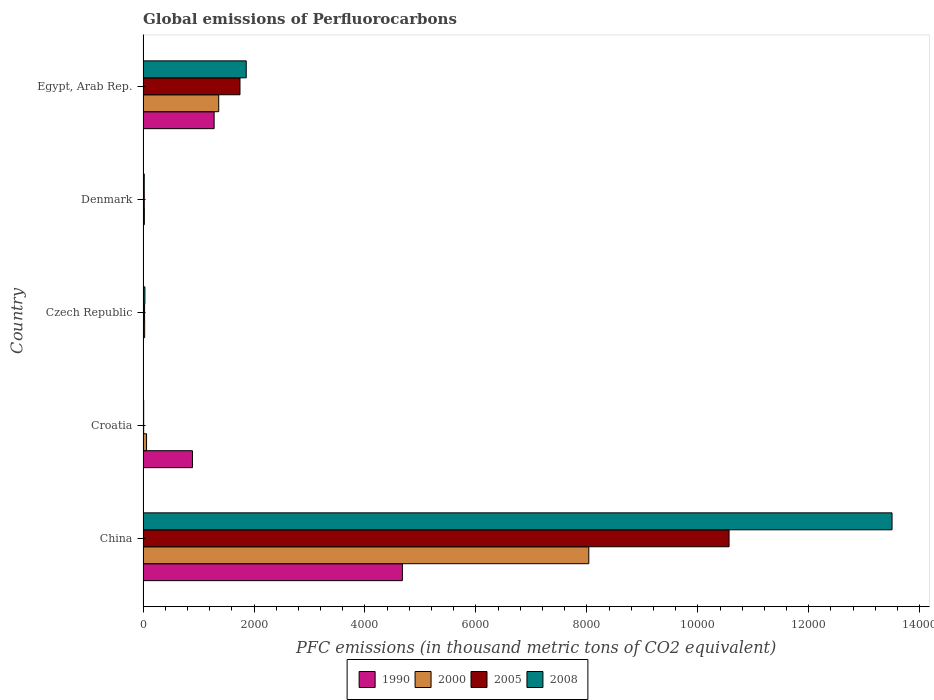How many different coloured bars are there?
Your response must be concise. 4. Are the number of bars per tick equal to the number of legend labels?
Keep it short and to the point. Yes. How many bars are there on the 5th tick from the top?
Make the answer very short. 4. How many bars are there on the 2nd tick from the bottom?
Make the answer very short. 4. What is the label of the 2nd group of bars from the top?
Your answer should be compact. Denmark. In how many cases, is the number of bars for a given country not equal to the number of legend labels?
Your response must be concise. 0. Across all countries, what is the maximum global emissions of Perfluorocarbons in 2000?
Provide a short and direct response. 8034.4. Across all countries, what is the minimum global emissions of Perfluorocarbons in 2008?
Provide a succinct answer. 11. In which country was the global emissions of Perfluorocarbons in 2008 maximum?
Ensure brevity in your answer.  China. In which country was the global emissions of Perfluorocarbons in 2005 minimum?
Your answer should be compact. Croatia. What is the total global emissions of Perfluorocarbons in 2005 in the graph?
Your answer should be compact. 1.24e+04. What is the difference between the global emissions of Perfluorocarbons in 1990 in China and that in Czech Republic?
Your answer should be compact. 4671.7. What is the difference between the global emissions of Perfluorocarbons in 1990 in Egypt, Arab Rep. and the global emissions of Perfluorocarbons in 2008 in Denmark?
Ensure brevity in your answer.  1259.4. What is the average global emissions of Perfluorocarbons in 1990 per country?
Provide a short and direct response. 1369.98. What is the difference between the global emissions of Perfluorocarbons in 2000 and global emissions of Perfluorocarbons in 2005 in China?
Your answer should be compact. -2528.4. In how many countries, is the global emissions of Perfluorocarbons in 2000 greater than 10800 thousand metric tons?
Give a very brief answer. 0. What is the ratio of the global emissions of Perfluorocarbons in 2008 in Croatia to that in Egypt, Arab Rep.?
Make the answer very short. 0.01. Is the global emissions of Perfluorocarbons in 1990 in China less than that in Croatia?
Offer a terse response. No. Is the difference between the global emissions of Perfluorocarbons in 2000 in Denmark and Egypt, Arab Rep. greater than the difference between the global emissions of Perfluorocarbons in 2005 in Denmark and Egypt, Arab Rep.?
Offer a terse response. Yes. What is the difference between the highest and the second highest global emissions of Perfluorocarbons in 2008?
Your answer should be compact. 1.16e+04. What is the difference between the highest and the lowest global emissions of Perfluorocarbons in 1990?
Give a very brief answer. 4673.1. In how many countries, is the global emissions of Perfluorocarbons in 2000 greater than the average global emissions of Perfluorocarbons in 2000 taken over all countries?
Provide a short and direct response. 1. Is the sum of the global emissions of Perfluorocarbons in 1990 in Croatia and Denmark greater than the maximum global emissions of Perfluorocarbons in 2000 across all countries?
Offer a very short reply. No. Is it the case that in every country, the sum of the global emissions of Perfluorocarbons in 2008 and global emissions of Perfluorocarbons in 1990 is greater than the sum of global emissions of Perfluorocarbons in 2005 and global emissions of Perfluorocarbons in 2000?
Give a very brief answer. No. How many bars are there?
Provide a short and direct response. 20. Are all the bars in the graph horizontal?
Your answer should be very brief. Yes. Does the graph contain any zero values?
Your answer should be very brief. No. Where does the legend appear in the graph?
Ensure brevity in your answer.  Bottom center. How many legend labels are there?
Offer a terse response. 4. What is the title of the graph?
Ensure brevity in your answer.  Global emissions of Perfluorocarbons. Does "2015" appear as one of the legend labels in the graph?
Provide a succinct answer. No. What is the label or title of the X-axis?
Give a very brief answer. PFC emissions (in thousand metric tons of CO2 equivalent). What is the PFC emissions (in thousand metric tons of CO2 equivalent) in 1990 in China?
Give a very brief answer. 4674.5. What is the PFC emissions (in thousand metric tons of CO2 equivalent) in 2000 in China?
Your response must be concise. 8034.4. What is the PFC emissions (in thousand metric tons of CO2 equivalent) in 2005 in China?
Make the answer very short. 1.06e+04. What is the PFC emissions (in thousand metric tons of CO2 equivalent) in 2008 in China?
Make the answer very short. 1.35e+04. What is the PFC emissions (in thousand metric tons of CO2 equivalent) of 1990 in Croatia?
Ensure brevity in your answer.  890.4. What is the PFC emissions (in thousand metric tons of CO2 equivalent) of 2000 in Croatia?
Your answer should be compact. 63. What is the PFC emissions (in thousand metric tons of CO2 equivalent) in 2000 in Czech Republic?
Offer a terse response. 28.8. What is the PFC emissions (in thousand metric tons of CO2 equivalent) in 2005 in Czech Republic?
Your answer should be compact. 27.5. What is the PFC emissions (in thousand metric tons of CO2 equivalent) in 2008 in Czech Republic?
Give a very brief answer. 33.3. What is the PFC emissions (in thousand metric tons of CO2 equivalent) in 1990 in Denmark?
Keep it short and to the point. 1.4. What is the PFC emissions (in thousand metric tons of CO2 equivalent) in 2000 in Denmark?
Your answer should be compact. 23.4. What is the PFC emissions (in thousand metric tons of CO2 equivalent) in 2008 in Denmark?
Give a very brief answer. 21.4. What is the PFC emissions (in thousand metric tons of CO2 equivalent) in 1990 in Egypt, Arab Rep.?
Your answer should be very brief. 1280.8. What is the PFC emissions (in thousand metric tons of CO2 equivalent) in 2000 in Egypt, Arab Rep.?
Provide a succinct answer. 1363.8. What is the PFC emissions (in thousand metric tons of CO2 equivalent) in 2005 in Egypt, Arab Rep.?
Provide a short and direct response. 1747.1. What is the PFC emissions (in thousand metric tons of CO2 equivalent) in 2008 in Egypt, Arab Rep.?
Your answer should be very brief. 1859.8. Across all countries, what is the maximum PFC emissions (in thousand metric tons of CO2 equivalent) in 1990?
Ensure brevity in your answer.  4674.5. Across all countries, what is the maximum PFC emissions (in thousand metric tons of CO2 equivalent) in 2000?
Offer a terse response. 8034.4. Across all countries, what is the maximum PFC emissions (in thousand metric tons of CO2 equivalent) of 2005?
Provide a short and direct response. 1.06e+04. Across all countries, what is the maximum PFC emissions (in thousand metric tons of CO2 equivalent) in 2008?
Ensure brevity in your answer.  1.35e+04. Across all countries, what is the minimum PFC emissions (in thousand metric tons of CO2 equivalent) in 1990?
Keep it short and to the point. 1.4. Across all countries, what is the minimum PFC emissions (in thousand metric tons of CO2 equivalent) of 2000?
Offer a terse response. 23.4. Across all countries, what is the minimum PFC emissions (in thousand metric tons of CO2 equivalent) of 2005?
Ensure brevity in your answer.  10.9. What is the total PFC emissions (in thousand metric tons of CO2 equivalent) in 1990 in the graph?
Make the answer very short. 6849.9. What is the total PFC emissions (in thousand metric tons of CO2 equivalent) in 2000 in the graph?
Your answer should be compact. 9513.4. What is the total PFC emissions (in thousand metric tons of CO2 equivalent) of 2005 in the graph?
Ensure brevity in your answer.  1.24e+04. What is the total PFC emissions (in thousand metric tons of CO2 equivalent) of 2008 in the graph?
Ensure brevity in your answer.  1.54e+04. What is the difference between the PFC emissions (in thousand metric tons of CO2 equivalent) of 1990 in China and that in Croatia?
Ensure brevity in your answer.  3784.1. What is the difference between the PFC emissions (in thousand metric tons of CO2 equivalent) in 2000 in China and that in Croatia?
Make the answer very short. 7971.4. What is the difference between the PFC emissions (in thousand metric tons of CO2 equivalent) in 2005 in China and that in Croatia?
Ensure brevity in your answer.  1.06e+04. What is the difference between the PFC emissions (in thousand metric tons of CO2 equivalent) in 2008 in China and that in Croatia?
Provide a succinct answer. 1.35e+04. What is the difference between the PFC emissions (in thousand metric tons of CO2 equivalent) of 1990 in China and that in Czech Republic?
Your answer should be compact. 4671.7. What is the difference between the PFC emissions (in thousand metric tons of CO2 equivalent) in 2000 in China and that in Czech Republic?
Your response must be concise. 8005.6. What is the difference between the PFC emissions (in thousand metric tons of CO2 equivalent) in 2005 in China and that in Czech Republic?
Your answer should be compact. 1.05e+04. What is the difference between the PFC emissions (in thousand metric tons of CO2 equivalent) in 2008 in China and that in Czech Republic?
Provide a short and direct response. 1.35e+04. What is the difference between the PFC emissions (in thousand metric tons of CO2 equivalent) of 1990 in China and that in Denmark?
Keep it short and to the point. 4673.1. What is the difference between the PFC emissions (in thousand metric tons of CO2 equivalent) in 2000 in China and that in Denmark?
Offer a terse response. 8011. What is the difference between the PFC emissions (in thousand metric tons of CO2 equivalent) of 2005 in China and that in Denmark?
Offer a terse response. 1.05e+04. What is the difference between the PFC emissions (in thousand metric tons of CO2 equivalent) of 2008 in China and that in Denmark?
Your answer should be compact. 1.35e+04. What is the difference between the PFC emissions (in thousand metric tons of CO2 equivalent) of 1990 in China and that in Egypt, Arab Rep.?
Keep it short and to the point. 3393.7. What is the difference between the PFC emissions (in thousand metric tons of CO2 equivalent) in 2000 in China and that in Egypt, Arab Rep.?
Give a very brief answer. 6670.6. What is the difference between the PFC emissions (in thousand metric tons of CO2 equivalent) in 2005 in China and that in Egypt, Arab Rep.?
Provide a succinct answer. 8815.7. What is the difference between the PFC emissions (in thousand metric tons of CO2 equivalent) in 2008 in China and that in Egypt, Arab Rep.?
Keep it short and to the point. 1.16e+04. What is the difference between the PFC emissions (in thousand metric tons of CO2 equivalent) in 1990 in Croatia and that in Czech Republic?
Provide a short and direct response. 887.6. What is the difference between the PFC emissions (in thousand metric tons of CO2 equivalent) of 2000 in Croatia and that in Czech Republic?
Provide a short and direct response. 34.2. What is the difference between the PFC emissions (in thousand metric tons of CO2 equivalent) in 2005 in Croatia and that in Czech Republic?
Ensure brevity in your answer.  -16.6. What is the difference between the PFC emissions (in thousand metric tons of CO2 equivalent) in 2008 in Croatia and that in Czech Republic?
Your response must be concise. -22.3. What is the difference between the PFC emissions (in thousand metric tons of CO2 equivalent) of 1990 in Croatia and that in Denmark?
Your response must be concise. 889. What is the difference between the PFC emissions (in thousand metric tons of CO2 equivalent) in 2000 in Croatia and that in Denmark?
Provide a short and direct response. 39.6. What is the difference between the PFC emissions (in thousand metric tons of CO2 equivalent) of 1990 in Croatia and that in Egypt, Arab Rep.?
Provide a succinct answer. -390.4. What is the difference between the PFC emissions (in thousand metric tons of CO2 equivalent) in 2000 in Croatia and that in Egypt, Arab Rep.?
Your response must be concise. -1300.8. What is the difference between the PFC emissions (in thousand metric tons of CO2 equivalent) of 2005 in Croatia and that in Egypt, Arab Rep.?
Offer a very short reply. -1736.2. What is the difference between the PFC emissions (in thousand metric tons of CO2 equivalent) of 2008 in Croatia and that in Egypt, Arab Rep.?
Offer a terse response. -1848.8. What is the difference between the PFC emissions (in thousand metric tons of CO2 equivalent) of 1990 in Czech Republic and that in Denmark?
Make the answer very short. 1.4. What is the difference between the PFC emissions (in thousand metric tons of CO2 equivalent) in 2000 in Czech Republic and that in Denmark?
Provide a succinct answer. 5.4. What is the difference between the PFC emissions (in thousand metric tons of CO2 equivalent) in 1990 in Czech Republic and that in Egypt, Arab Rep.?
Give a very brief answer. -1278. What is the difference between the PFC emissions (in thousand metric tons of CO2 equivalent) of 2000 in Czech Republic and that in Egypt, Arab Rep.?
Keep it short and to the point. -1335. What is the difference between the PFC emissions (in thousand metric tons of CO2 equivalent) in 2005 in Czech Republic and that in Egypt, Arab Rep.?
Keep it short and to the point. -1719.6. What is the difference between the PFC emissions (in thousand metric tons of CO2 equivalent) of 2008 in Czech Republic and that in Egypt, Arab Rep.?
Ensure brevity in your answer.  -1826.5. What is the difference between the PFC emissions (in thousand metric tons of CO2 equivalent) in 1990 in Denmark and that in Egypt, Arab Rep.?
Make the answer very short. -1279.4. What is the difference between the PFC emissions (in thousand metric tons of CO2 equivalent) in 2000 in Denmark and that in Egypt, Arab Rep.?
Offer a very short reply. -1340.4. What is the difference between the PFC emissions (in thousand metric tons of CO2 equivalent) of 2005 in Denmark and that in Egypt, Arab Rep.?
Keep it short and to the point. -1725.6. What is the difference between the PFC emissions (in thousand metric tons of CO2 equivalent) in 2008 in Denmark and that in Egypt, Arab Rep.?
Your answer should be very brief. -1838.4. What is the difference between the PFC emissions (in thousand metric tons of CO2 equivalent) of 1990 in China and the PFC emissions (in thousand metric tons of CO2 equivalent) of 2000 in Croatia?
Your answer should be compact. 4611.5. What is the difference between the PFC emissions (in thousand metric tons of CO2 equivalent) in 1990 in China and the PFC emissions (in thousand metric tons of CO2 equivalent) in 2005 in Croatia?
Your response must be concise. 4663.6. What is the difference between the PFC emissions (in thousand metric tons of CO2 equivalent) in 1990 in China and the PFC emissions (in thousand metric tons of CO2 equivalent) in 2008 in Croatia?
Make the answer very short. 4663.5. What is the difference between the PFC emissions (in thousand metric tons of CO2 equivalent) of 2000 in China and the PFC emissions (in thousand metric tons of CO2 equivalent) of 2005 in Croatia?
Your answer should be very brief. 8023.5. What is the difference between the PFC emissions (in thousand metric tons of CO2 equivalent) in 2000 in China and the PFC emissions (in thousand metric tons of CO2 equivalent) in 2008 in Croatia?
Ensure brevity in your answer.  8023.4. What is the difference between the PFC emissions (in thousand metric tons of CO2 equivalent) in 2005 in China and the PFC emissions (in thousand metric tons of CO2 equivalent) in 2008 in Croatia?
Make the answer very short. 1.06e+04. What is the difference between the PFC emissions (in thousand metric tons of CO2 equivalent) of 1990 in China and the PFC emissions (in thousand metric tons of CO2 equivalent) of 2000 in Czech Republic?
Provide a succinct answer. 4645.7. What is the difference between the PFC emissions (in thousand metric tons of CO2 equivalent) in 1990 in China and the PFC emissions (in thousand metric tons of CO2 equivalent) in 2005 in Czech Republic?
Make the answer very short. 4647. What is the difference between the PFC emissions (in thousand metric tons of CO2 equivalent) in 1990 in China and the PFC emissions (in thousand metric tons of CO2 equivalent) in 2008 in Czech Republic?
Give a very brief answer. 4641.2. What is the difference between the PFC emissions (in thousand metric tons of CO2 equivalent) of 2000 in China and the PFC emissions (in thousand metric tons of CO2 equivalent) of 2005 in Czech Republic?
Provide a short and direct response. 8006.9. What is the difference between the PFC emissions (in thousand metric tons of CO2 equivalent) in 2000 in China and the PFC emissions (in thousand metric tons of CO2 equivalent) in 2008 in Czech Republic?
Your response must be concise. 8001.1. What is the difference between the PFC emissions (in thousand metric tons of CO2 equivalent) of 2005 in China and the PFC emissions (in thousand metric tons of CO2 equivalent) of 2008 in Czech Republic?
Your answer should be compact. 1.05e+04. What is the difference between the PFC emissions (in thousand metric tons of CO2 equivalent) in 1990 in China and the PFC emissions (in thousand metric tons of CO2 equivalent) in 2000 in Denmark?
Your answer should be very brief. 4651.1. What is the difference between the PFC emissions (in thousand metric tons of CO2 equivalent) of 1990 in China and the PFC emissions (in thousand metric tons of CO2 equivalent) of 2005 in Denmark?
Provide a short and direct response. 4653. What is the difference between the PFC emissions (in thousand metric tons of CO2 equivalent) of 1990 in China and the PFC emissions (in thousand metric tons of CO2 equivalent) of 2008 in Denmark?
Keep it short and to the point. 4653.1. What is the difference between the PFC emissions (in thousand metric tons of CO2 equivalent) of 2000 in China and the PFC emissions (in thousand metric tons of CO2 equivalent) of 2005 in Denmark?
Provide a succinct answer. 8012.9. What is the difference between the PFC emissions (in thousand metric tons of CO2 equivalent) of 2000 in China and the PFC emissions (in thousand metric tons of CO2 equivalent) of 2008 in Denmark?
Ensure brevity in your answer.  8013. What is the difference between the PFC emissions (in thousand metric tons of CO2 equivalent) in 2005 in China and the PFC emissions (in thousand metric tons of CO2 equivalent) in 2008 in Denmark?
Keep it short and to the point. 1.05e+04. What is the difference between the PFC emissions (in thousand metric tons of CO2 equivalent) of 1990 in China and the PFC emissions (in thousand metric tons of CO2 equivalent) of 2000 in Egypt, Arab Rep.?
Give a very brief answer. 3310.7. What is the difference between the PFC emissions (in thousand metric tons of CO2 equivalent) of 1990 in China and the PFC emissions (in thousand metric tons of CO2 equivalent) of 2005 in Egypt, Arab Rep.?
Make the answer very short. 2927.4. What is the difference between the PFC emissions (in thousand metric tons of CO2 equivalent) of 1990 in China and the PFC emissions (in thousand metric tons of CO2 equivalent) of 2008 in Egypt, Arab Rep.?
Provide a succinct answer. 2814.7. What is the difference between the PFC emissions (in thousand metric tons of CO2 equivalent) of 2000 in China and the PFC emissions (in thousand metric tons of CO2 equivalent) of 2005 in Egypt, Arab Rep.?
Offer a terse response. 6287.3. What is the difference between the PFC emissions (in thousand metric tons of CO2 equivalent) of 2000 in China and the PFC emissions (in thousand metric tons of CO2 equivalent) of 2008 in Egypt, Arab Rep.?
Ensure brevity in your answer.  6174.6. What is the difference between the PFC emissions (in thousand metric tons of CO2 equivalent) in 2005 in China and the PFC emissions (in thousand metric tons of CO2 equivalent) in 2008 in Egypt, Arab Rep.?
Ensure brevity in your answer.  8703. What is the difference between the PFC emissions (in thousand metric tons of CO2 equivalent) in 1990 in Croatia and the PFC emissions (in thousand metric tons of CO2 equivalent) in 2000 in Czech Republic?
Make the answer very short. 861.6. What is the difference between the PFC emissions (in thousand metric tons of CO2 equivalent) of 1990 in Croatia and the PFC emissions (in thousand metric tons of CO2 equivalent) of 2005 in Czech Republic?
Your answer should be very brief. 862.9. What is the difference between the PFC emissions (in thousand metric tons of CO2 equivalent) in 1990 in Croatia and the PFC emissions (in thousand metric tons of CO2 equivalent) in 2008 in Czech Republic?
Keep it short and to the point. 857.1. What is the difference between the PFC emissions (in thousand metric tons of CO2 equivalent) in 2000 in Croatia and the PFC emissions (in thousand metric tons of CO2 equivalent) in 2005 in Czech Republic?
Provide a succinct answer. 35.5. What is the difference between the PFC emissions (in thousand metric tons of CO2 equivalent) of 2000 in Croatia and the PFC emissions (in thousand metric tons of CO2 equivalent) of 2008 in Czech Republic?
Your answer should be compact. 29.7. What is the difference between the PFC emissions (in thousand metric tons of CO2 equivalent) in 2005 in Croatia and the PFC emissions (in thousand metric tons of CO2 equivalent) in 2008 in Czech Republic?
Your response must be concise. -22.4. What is the difference between the PFC emissions (in thousand metric tons of CO2 equivalent) of 1990 in Croatia and the PFC emissions (in thousand metric tons of CO2 equivalent) of 2000 in Denmark?
Your answer should be very brief. 867. What is the difference between the PFC emissions (in thousand metric tons of CO2 equivalent) of 1990 in Croatia and the PFC emissions (in thousand metric tons of CO2 equivalent) of 2005 in Denmark?
Provide a succinct answer. 868.9. What is the difference between the PFC emissions (in thousand metric tons of CO2 equivalent) of 1990 in Croatia and the PFC emissions (in thousand metric tons of CO2 equivalent) of 2008 in Denmark?
Provide a short and direct response. 869. What is the difference between the PFC emissions (in thousand metric tons of CO2 equivalent) in 2000 in Croatia and the PFC emissions (in thousand metric tons of CO2 equivalent) in 2005 in Denmark?
Your response must be concise. 41.5. What is the difference between the PFC emissions (in thousand metric tons of CO2 equivalent) of 2000 in Croatia and the PFC emissions (in thousand metric tons of CO2 equivalent) of 2008 in Denmark?
Provide a succinct answer. 41.6. What is the difference between the PFC emissions (in thousand metric tons of CO2 equivalent) in 2005 in Croatia and the PFC emissions (in thousand metric tons of CO2 equivalent) in 2008 in Denmark?
Your answer should be very brief. -10.5. What is the difference between the PFC emissions (in thousand metric tons of CO2 equivalent) in 1990 in Croatia and the PFC emissions (in thousand metric tons of CO2 equivalent) in 2000 in Egypt, Arab Rep.?
Make the answer very short. -473.4. What is the difference between the PFC emissions (in thousand metric tons of CO2 equivalent) in 1990 in Croatia and the PFC emissions (in thousand metric tons of CO2 equivalent) in 2005 in Egypt, Arab Rep.?
Provide a short and direct response. -856.7. What is the difference between the PFC emissions (in thousand metric tons of CO2 equivalent) of 1990 in Croatia and the PFC emissions (in thousand metric tons of CO2 equivalent) of 2008 in Egypt, Arab Rep.?
Your answer should be compact. -969.4. What is the difference between the PFC emissions (in thousand metric tons of CO2 equivalent) in 2000 in Croatia and the PFC emissions (in thousand metric tons of CO2 equivalent) in 2005 in Egypt, Arab Rep.?
Make the answer very short. -1684.1. What is the difference between the PFC emissions (in thousand metric tons of CO2 equivalent) of 2000 in Croatia and the PFC emissions (in thousand metric tons of CO2 equivalent) of 2008 in Egypt, Arab Rep.?
Offer a terse response. -1796.8. What is the difference between the PFC emissions (in thousand metric tons of CO2 equivalent) of 2005 in Croatia and the PFC emissions (in thousand metric tons of CO2 equivalent) of 2008 in Egypt, Arab Rep.?
Your answer should be very brief. -1848.9. What is the difference between the PFC emissions (in thousand metric tons of CO2 equivalent) in 1990 in Czech Republic and the PFC emissions (in thousand metric tons of CO2 equivalent) in 2000 in Denmark?
Your answer should be very brief. -20.6. What is the difference between the PFC emissions (in thousand metric tons of CO2 equivalent) in 1990 in Czech Republic and the PFC emissions (in thousand metric tons of CO2 equivalent) in 2005 in Denmark?
Your answer should be very brief. -18.7. What is the difference between the PFC emissions (in thousand metric tons of CO2 equivalent) in 1990 in Czech Republic and the PFC emissions (in thousand metric tons of CO2 equivalent) in 2008 in Denmark?
Make the answer very short. -18.6. What is the difference between the PFC emissions (in thousand metric tons of CO2 equivalent) in 2005 in Czech Republic and the PFC emissions (in thousand metric tons of CO2 equivalent) in 2008 in Denmark?
Your answer should be compact. 6.1. What is the difference between the PFC emissions (in thousand metric tons of CO2 equivalent) in 1990 in Czech Republic and the PFC emissions (in thousand metric tons of CO2 equivalent) in 2000 in Egypt, Arab Rep.?
Ensure brevity in your answer.  -1361. What is the difference between the PFC emissions (in thousand metric tons of CO2 equivalent) in 1990 in Czech Republic and the PFC emissions (in thousand metric tons of CO2 equivalent) in 2005 in Egypt, Arab Rep.?
Your response must be concise. -1744.3. What is the difference between the PFC emissions (in thousand metric tons of CO2 equivalent) in 1990 in Czech Republic and the PFC emissions (in thousand metric tons of CO2 equivalent) in 2008 in Egypt, Arab Rep.?
Offer a very short reply. -1857. What is the difference between the PFC emissions (in thousand metric tons of CO2 equivalent) of 2000 in Czech Republic and the PFC emissions (in thousand metric tons of CO2 equivalent) of 2005 in Egypt, Arab Rep.?
Provide a succinct answer. -1718.3. What is the difference between the PFC emissions (in thousand metric tons of CO2 equivalent) in 2000 in Czech Republic and the PFC emissions (in thousand metric tons of CO2 equivalent) in 2008 in Egypt, Arab Rep.?
Your response must be concise. -1831. What is the difference between the PFC emissions (in thousand metric tons of CO2 equivalent) in 2005 in Czech Republic and the PFC emissions (in thousand metric tons of CO2 equivalent) in 2008 in Egypt, Arab Rep.?
Your response must be concise. -1832.3. What is the difference between the PFC emissions (in thousand metric tons of CO2 equivalent) of 1990 in Denmark and the PFC emissions (in thousand metric tons of CO2 equivalent) of 2000 in Egypt, Arab Rep.?
Provide a succinct answer. -1362.4. What is the difference between the PFC emissions (in thousand metric tons of CO2 equivalent) in 1990 in Denmark and the PFC emissions (in thousand metric tons of CO2 equivalent) in 2005 in Egypt, Arab Rep.?
Your answer should be compact. -1745.7. What is the difference between the PFC emissions (in thousand metric tons of CO2 equivalent) in 1990 in Denmark and the PFC emissions (in thousand metric tons of CO2 equivalent) in 2008 in Egypt, Arab Rep.?
Your answer should be compact. -1858.4. What is the difference between the PFC emissions (in thousand metric tons of CO2 equivalent) in 2000 in Denmark and the PFC emissions (in thousand metric tons of CO2 equivalent) in 2005 in Egypt, Arab Rep.?
Offer a very short reply. -1723.7. What is the difference between the PFC emissions (in thousand metric tons of CO2 equivalent) in 2000 in Denmark and the PFC emissions (in thousand metric tons of CO2 equivalent) in 2008 in Egypt, Arab Rep.?
Ensure brevity in your answer.  -1836.4. What is the difference between the PFC emissions (in thousand metric tons of CO2 equivalent) in 2005 in Denmark and the PFC emissions (in thousand metric tons of CO2 equivalent) in 2008 in Egypt, Arab Rep.?
Give a very brief answer. -1838.3. What is the average PFC emissions (in thousand metric tons of CO2 equivalent) in 1990 per country?
Give a very brief answer. 1369.98. What is the average PFC emissions (in thousand metric tons of CO2 equivalent) of 2000 per country?
Your answer should be compact. 1902.68. What is the average PFC emissions (in thousand metric tons of CO2 equivalent) of 2005 per country?
Your answer should be very brief. 2473.96. What is the average PFC emissions (in thousand metric tons of CO2 equivalent) in 2008 per country?
Your response must be concise. 3085.22. What is the difference between the PFC emissions (in thousand metric tons of CO2 equivalent) in 1990 and PFC emissions (in thousand metric tons of CO2 equivalent) in 2000 in China?
Your response must be concise. -3359.9. What is the difference between the PFC emissions (in thousand metric tons of CO2 equivalent) of 1990 and PFC emissions (in thousand metric tons of CO2 equivalent) of 2005 in China?
Give a very brief answer. -5888.3. What is the difference between the PFC emissions (in thousand metric tons of CO2 equivalent) in 1990 and PFC emissions (in thousand metric tons of CO2 equivalent) in 2008 in China?
Your response must be concise. -8826.1. What is the difference between the PFC emissions (in thousand metric tons of CO2 equivalent) of 2000 and PFC emissions (in thousand metric tons of CO2 equivalent) of 2005 in China?
Your response must be concise. -2528.4. What is the difference between the PFC emissions (in thousand metric tons of CO2 equivalent) of 2000 and PFC emissions (in thousand metric tons of CO2 equivalent) of 2008 in China?
Ensure brevity in your answer.  -5466.2. What is the difference between the PFC emissions (in thousand metric tons of CO2 equivalent) of 2005 and PFC emissions (in thousand metric tons of CO2 equivalent) of 2008 in China?
Offer a very short reply. -2937.8. What is the difference between the PFC emissions (in thousand metric tons of CO2 equivalent) in 1990 and PFC emissions (in thousand metric tons of CO2 equivalent) in 2000 in Croatia?
Your answer should be very brief. 827.4. What is the difference between the PFC emissions (in thousand metric tons of CO2 equivalent) in 1990 and PFC emissions (in thousand metric tons of CO2 equivalent) in 2005 in Croatia?
Offer a very short reply. 879.5. What is the difference between the PFC emissions (in thousand metric tons of CO2 equivalent) in 1990 and PFC emissions (in thousand metric tons of CO2 equivalent) in 2008 in Croatia?
Your answer should be compact. 879.4. What is the difference between the PFC emissions (in thousand metric tons of CO2 equivalent) of 2000 and PFC emissions (in thousand metric tons of CO2 equivalent) of 2005 in Croatia?
Your answer should be very brief. 52.1. What is the difference between the PFC emissions (in thousand metric tons of CO2 equivalent) of 2000 and PFC emissions (in thousand metric tons of CO2 equivalent) of 2008 in Croatia?
Make the answer very short. 52. What is the difference between the PFC emissions (in thousand metric tons of CO2 equivalent) in 2005 and PFC emissions (in thousand metric tons of CO2 equivalent) in 2008 in Croatia?
Ensure brevity in your answer.  -0.1. What is the difference between the PFC emissions (in thousand metric tons of CO2 equivalent) of 1990 and PFC emissions (in thousand metric tons of CO2 equivalent) of 2000 in Czech Republic?
Make the answer very short. -26. What is the difference between the PFC emissions (in thousand metric tons of CO2 equivalent) in 1990 and PFC emissions (in thousand metric tons of CO2 equivalent) in 2005 in Czech Republic?
Keep it short and to the point. -24.7. What is the difference between the PFC emissions (in thousand metric tons of CO2 equivalent) of 1990 and PFC emissions (in thousand metric tons of CO2 equivalent) of 2008 in Czech Republic?
Offer a terse response. -30.5. What is the difference between the PFC emissions (in thousand metric tons of CO2 equivalent) of 2005 and PFC emissions (in thousand metric tons of CO2 equivalent) of 2008 in Czech Republic?
Ensure brevity in your answer.  -5.8. What is the difference between the PFC emissions (in thousand metric tons of CO2 equivalent) of 1990 and PFC emissions (in thousand metric tons of CO2 equivalent) of 2005 in Denmark?
Provide a succinct answer. -20.1. What is the difference between the PFC emissions (in thousand metric tons of CO2 equivalent) of 2000 and PFC emissions (in thousand metric tons of CO2 equivalent) of 2005 in Denmark?
Your response must be concise. 1.9. What is the difference between the PFC emissions (in thousand metric tons of CO2 equivalent) in 1990 and PFC emissions (in thousand metric tons of CO2 equivalent) in 2000 in Egypt, Arab Rep.?
Provide a short and direct response. -83. What is the difference between the PFC emissions (in thousand metric tons of CO2 equivalent) in 1990 and PFC emissions (in thousand metric tons of CO2 equivalent) in 2005 in Egypt, Arab Rep.?
Give a very brief answer. -466.3. What is the difference between the PFC emissions (in thousand metric tons of CO2 equivalent) in 1990 and PFC emissions (in thousand metric tons of CO2 equivalent) in 2008 in Egypt, Arab Rep.?
Keep it short and to the point. -579. What is the difference between the PFC emissions (in thousand metric tons of CO2 equivalent) in 2000 and PFC emissions (in thousand metric tons of CO2 equivalent) in 2005 in Egypt, Arab Rep.?
Make the answer very short. -383.3. What is the difference between the PFC emissions (in thousand metric tons of CO2 equivalent) in 2000 and PFC emissions (in thousand metric tons of CO2 equivalent) in 2008 in Egypt, Arab Rep.?
Your response must be concise. -496. What is the difference between the PFC emissions (in thousand metric tons of CO2 equivalent) in 2005 and PFC emissions (in thousand metric tons of CO2 equivalent) in 2008 in Egypt, Arab Rep.?
Provide a succinct answer. -112.7. What is the ratio of the PFC emissions (in thousand metric tons of CO2 equivalent) in 1990 in China to that in Croatia?
Your response must be concise. 5.25. What is the ratio of the PFC emissions (in thousand metric tons of CO2 equivalent) of 2000 in China to that in Croatia?
Provide a short and direct response. 127.53. What is the ratio of the PFC emissions (in thousand metric tons of CO2 equivalent) of 2005 in China to that in Croatia?
Give a very brief answer. 969.06. What is the ratio of the PFC emissions (in thousand metric tons of CO2 equivalent) of 2008 in China to that in Croatia?
Your response must be concise. 1227.33. What is the ratio of the PFC emissions (in thousand metric tons of CO2 equivalent) of 1990 in China to that in Czech Republic?
Offer a very short reply. 1669.46. What is the ratio of the PFC emissions (in thousand metric tons of CO2 equivalent) in 2000 in China to that in Czech Republic?
Offer a very short reply. 278.97. What is the ratio of the PFC emissions (in thousand metric tons of CO2 equivalent) in 2005 in China to that in Czech Republic?
Ensure brevity in your answer.  384.1. What is the ratio of the PFC emissions (in thousand metric tons of CO2 equivalent) in 2008 in China to that in Czech Republic?
Give a very brief answer. 405.42. What is the ratio of the PFC emissions (in thousand metric tons of CO2 equivalent) in 1990 in China to that in Denmark?
Ensure brevity in your answer.  3338.93. What is the ratio of the PFC emissions (in thousand metric tons of CO2 equivalent) of 2000 in China to that in Denmark?
Your answer should be compact. 343.35. What is the ratio of the PFC emissions (in thousand metric tons of CO2 equivalent) in 2005 in China to that in Denmark?
Make the answer very short. 491.29. What is the ratio of the PFC emissions (in thousand metric tons of CO2 equivalent) of 2008 in China to that in Denmark?
Your answer should be compact. 630.87. What is the ratio of the PFC emissions (in thousand metric tons of CO2 equivalent) in 1990 in China to that in Egypt, Arab Rep.?
Your answer should be compact. 3.65. What is the ratio of the PFC emissions (in thousand metric tons of CO2 equivalent) of 2000 in China to that in Egypt, Arab Rep.?
Provide a short and direct response. 5.89. What is the ratio of the PFC emissions (in thousand metric tons of CO2 equivalent) of 2005 in China to that in Egypt, Arab Rep.?
Provide a short and direct response. 6.05. What is the ratio of the PFC emissions (in thousand metric tons of CO2 equivalent) in 2008 in China to that in Egypt, Arab Rep.?
Ensure brevity in your answer.  7.26. What is the ratio of the PFC emissions (in thousand metric tons of CO2 equivalent) of 1990 in Croatia to that in Czech Republic?
Keep it short and to the point. 318. What is the ratio of the PFC emissions (in thousand metric tons of CO2 equivalent) in 2000 in Croatia to that in Czech Republic?
Provide a short and direct response. 2.19. What is the ratio of the PFC emissions (in thousand metric tons of CO2 equivalent) in 2005 in Croatia to that in Czech Republic?
Ensure brevity in your answer.  0.4. What is the ratio of the PFC emissions (in thousand metric tons of CO2 equivalent) in 2008 in Croatia to that in Czech Republic?
Provide a short and direct response. 0.33. What is the ratio of the PFC emissions (in thousand metric tons of CO2 equivalent) in 1990 in Croatia to that in Denmark?
Give a very brief answer. 636. What is the ratio of the PFC emissions (in thousand metric tons of CO2 equivalent) of 2000 in Croatia to that in Denmark?
Your answer should be very brief. 2.69. What is the ratio of the PFC emissions (in thousand metric tons of CO2 equivalent) of 2005 in Croatia to that in Denmark?
Provide a succinct answer. 0.51. What is the ratio of the PFC emissions (in thousand metric tons of CO2 equivalent) in 2008 in Croatia to that in Denmark?
Keep it short and to the point. 0.51. What is the ratio of the PFC emissions (in thousand metric tons of CO2 equivalent) in 1990 in Croatia to that in Egypt, Arab Rep.?
Provide a short and direct response. 0.7. What is the ratio of the PFC emissions (in thousand metric tons of CO2 equivalent) of 2000 in Croatia to that in Egypt, Arab Rep.?
Provide a short and direct response. 0.05. What is the ratio of the PFC emissions (in thousand metric tons of CO2 equivalent) of 2005 in Croatia to that in Egypt, Arab Rep.?
Keep it short and to the point. 0.01. What is the ratio of the PFC emissions (in thousand metric tons of CO2 equivalent) in 2008 in Croatia to that in Egypt, Arab Rep.?
Your answer should be compact. 0.01. What is the ratio of the PFC emissions (in thousand metric tons of CO2 equivalent) in 1990 in Czech Republic to that in Denmark?
Ensure brevity in your answer.  2. What is the ratio of the PFC emissions (in thousand metric tons of CO2 equivalent) in 2000 in Czech Republic to that in Denmark?
Your answer should be compact. 1.23. What is the ratio of the PFC emissions (in thousand metric tons of CO2 equivalent) of 2005 in Czech Republic to that in Denmark?
Give a very brief answer. 1.28. What is the ratio of the PFC emissions (in thousand metric tons of CO2 equivalent) of 2008 in Czech Republic to that in Denmark?
Your answer should be very brief. 1.56. What is the ratio of the PFC emissions (in thousand metric tons of CO2 equivalent) in 1990 in Czech Republic to that in Egypt, Arab Rep.?
Provide a short and direct response. 0. What is the ratio of the PFC emissions (in thousand metric tons of CO2 equivalent) of 2000 in Czech Republic to that in Egypt, Arab Rep.?
Give a very brief answer. 0.02. What is the ratio of the PFC emissions (in thousand metric tons of CO2 equivalent) in 2005 in Czech Republic to that in Egypt, Arab Rep.?
Keep it short and to the point. 0.02. What is the ratio of the PFC emissions (in thousand metric tons of CO2 equivalent) of 2008 in Czech Republic to that in Egypt, Arab Rep.?
Give a very brief answer. 0.02. What is the ratio of the PFC emissions (in thousand metric tons of CO2 equivalent) of 1990 in Denmark to that in Egypt, Arab Rep.?
Provide a succinct answer. 0. What is the ratio of the PFC emissions (in thousand metric tons of CO2 equivalent) in 2000 in Denmark to that in Egypt, Arab Rep.?
Make the answer very short. 0.02. What is the ratio of the PFC emissions (in thousand metric tons of CO2 equivalent) of 2005 in Denmark to that in Egypt, Arab Rep.?
Ensure brevity in your answer.  0.01. What is the ratio of the PFC emissions (in thousand metric tons of CO2 equivalent) in 2008 in Denmark to that in Egypt, Arab Rep.?
Keep it short and to the point. 0.01. What is the difference between the highest and the second highest PFC emissions (in thousand metric tons of CO2 equivalent) of 1990?
Give a very brief answer. 3393.7. What is the difference between the highest and the second highest PFC emissions (in thousand metric tons of CO2 equivalent) in 2000?
Offer a very short reply. 6670.6. What is the difference between the highest and the second highest PFC emissions (in thousand metric tons of CO2 equivalent) of 2005?
Provide a short and direct response. 8815.7. What is the difference between the highest and the second highest PFC emissions (in thousand metric tons of CO2 equivalent) of 2008?
Ensure brevity in your answer.  1.16e+04. What is the difference between the highest and the lowest PFC emissions (in thousand metric tons of CO2 equivalent) in 1990?
Your response must be concise. 4673.1. What is the difference between the highest and the lowest PFC emissions (in thousand metric tons of CO2 equivalent) in 2000?
Your answer should be very brief. 8011. What is the difference between the highest and the lowest PFC emissions (in thousand metric tons of CO2 equivalent) of 2005?
Your answer should be very brief. 1.06e+04. What is the difference between the highest and the lowest PFC emissions (in thousand metric tons of CO2 equivalent) of 2008?
Provide a short and direct response. 1.35e+04. 